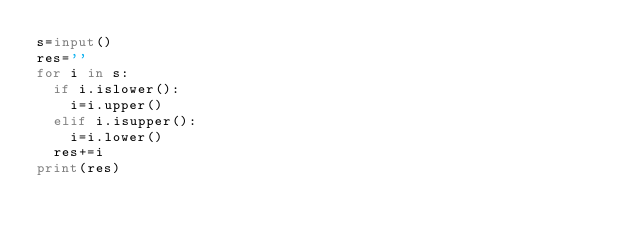<code> <loc_0><loc_0><loc_500><loc_500><_Python_>s=input()
res=''
for i in s:
  if i.islower():
    i=i.upper()
  elif i.isupper():
    i=i.lower() 
  res+=i
print(res)
</code> 